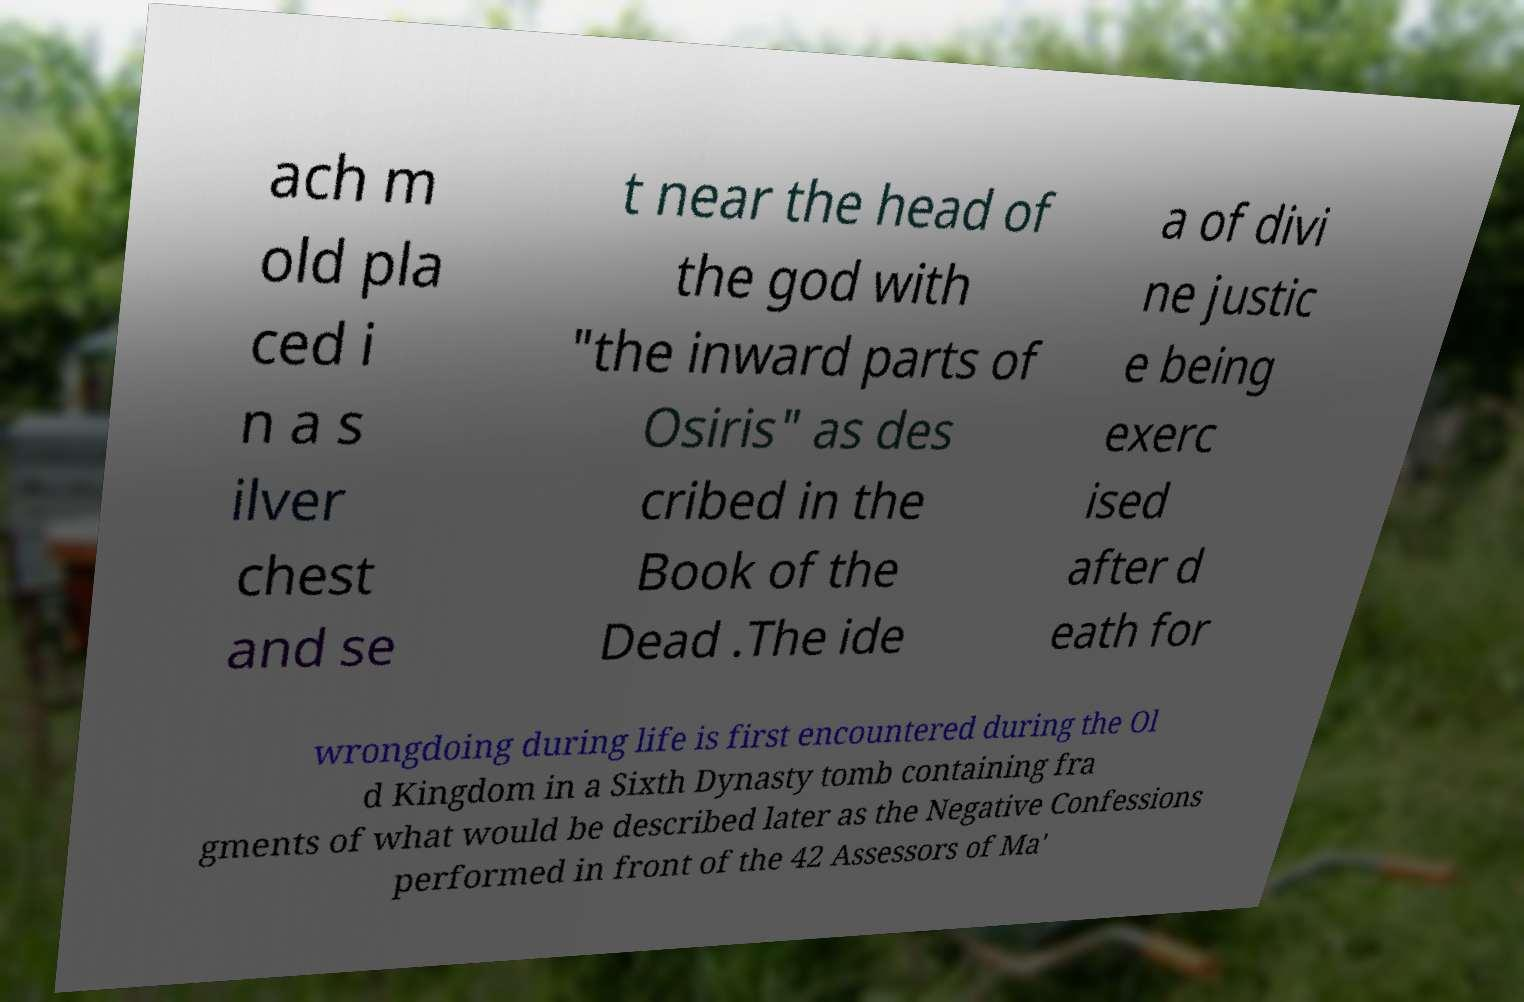Could you assist in decoding the text presented in this image and type it out clearly? ach m old pla ced i n a s ilver chest and se t near the head of the god with "the inward parts of Osiris" as des cribed in the Book of the Dead .The ide a of divi ne justic e being exerc ised after d eath for wrongdoing during life is first encountered during the Ol d Kingdom in a Sixth Dynasty tomb containing fra gments of what would be described later as the Negative Confessions performed in front of the 42 Assessors of Ma' 